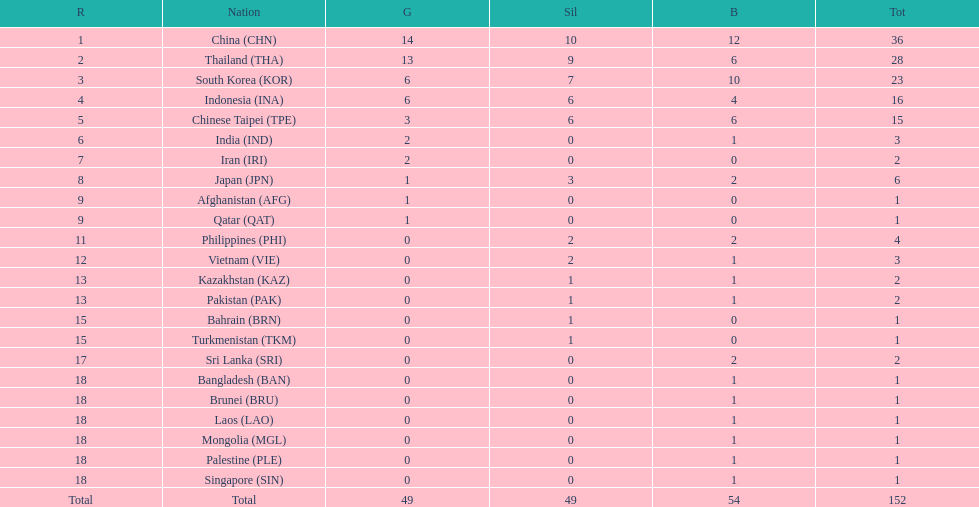Which nation finished first in total medals earned? China (CHN). 